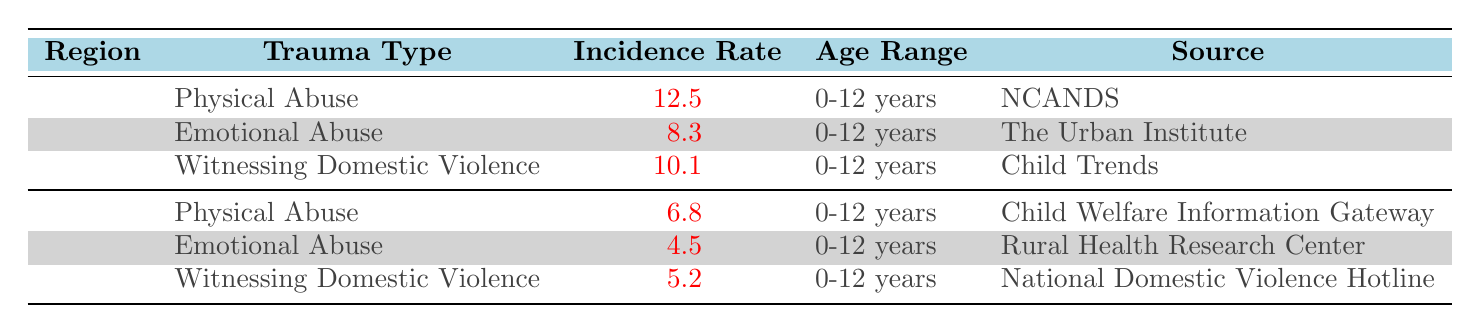What is the incidence rate of Physical Abuse in Urban areas? The table shows that the incidence rate for Physical Abuse under the Urban category is 12.5 per 1000.
Answer: 12.5 How many types of childhood trauma are reported in Rural settings? The table lists three types of childhood trauma in Rural settings: Physical Abuse, Emotional Abuse, and Witnessing Domestic Violence.
Answer: 3 What is the difference in the incidence rate of Emotional Abuse between Urban and Rural settings? The incidence rate for Emotional Abuse in Urban is 8.3, while in Rural it is 4.5. The difference is calculated as 8.3 - 4.5, which equals 3.8.
Answer: 3.8 Which region has a higher incidence rate for witnessing Domestic Violence? The table indicates that Urban areas have a higher incidence rate at 10.1 compared to 5.2 in Rural areas.
Answer: Urban What is the average incidence rate of Physical Abuse and Witnessing Domestic Violence combined in Urban settings? The rates for Physical Abuse and Witnessing Domestic Violence in Urban settings are 12.5 and 10.1, respectively. Summing these gives 12.5 + 10.1 = 22.6. Then, dividing by 2 gives an average of 22.6 / 2 = 11.3.
Answer: 11.3 Is the incidence rate of Emotional Abuse higher in Urban or Rural areas? The table shows an incidence rate of 8.3 in Urban areas and 4.5 in Rural areas, therefore it is higher in Urban areas.
Answer: Yes What is the total incidence rate of trauma types for Rural settings? The trauma types in Rural settings are Physical Abuse (6.8), Emotional Abuse (4.5), and Witnessing Domestic Violence (5.2). The total is 6.8 + 4.5 + 5.2 = 16.5.
Answer: 16.5 Which trauma type has the highest incidence rate in the table, and what is that rate? The highest incidence rate is for Physical Abuse in Urban settings at 12.5.
Answer: Physical Abuse, 12.5 How does the incidence rate of Witnessing Domestic Violence in Rural areas compare to Urban areas? The incidence rate for Witnessing Domestic Violence in Urban is 10.1, while in Rural it is 5.2. The Urban rate is higher by 10.1 - 5.2 = 4.9.
Answer: Urban is higher by 4.9 Is the source for the data on Emotional Abuse in Rural areas different from that in Urban areas? The source for Emotional Abuse in Rural is the Rural Health Research Center, whereas in Urban, it's from The Urban Institute. Therefore, they are different.
Answer: Yes What is the approximate incidence rate for all trauma types combined in Urban areas? Summing the rates for Urban trauma types gives 12.5 (Physical Abuse) + 8.3 (Emotional Abuse) + 10.1 (Witnessing Domestic Violence) = 30.9.
Answer: 30.9 